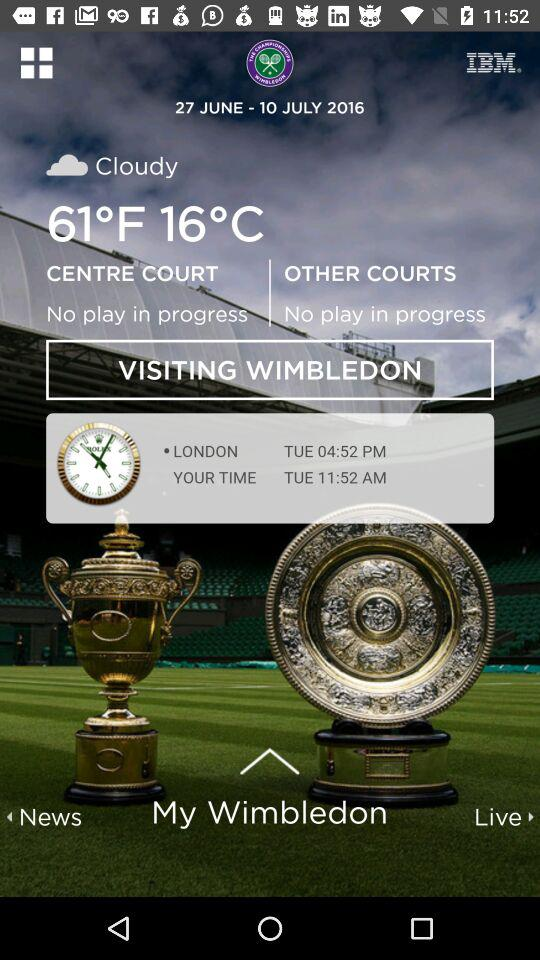What is the "YOUR TIME"? The "YOUR TIME" is Tuesday, 11:52 a.m. 